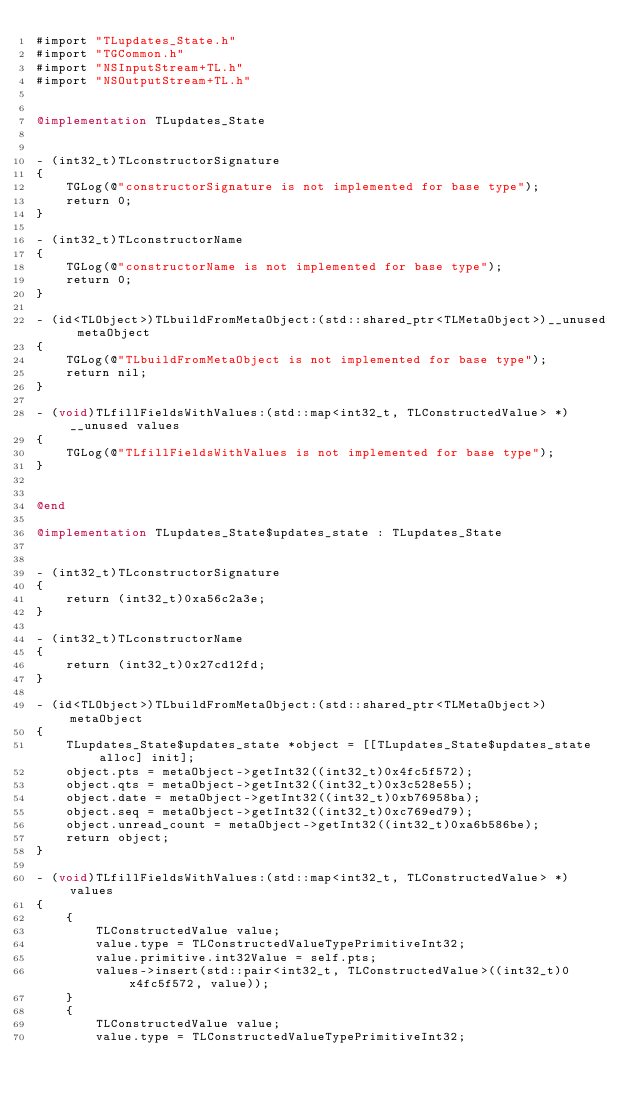<code> <loc_0><loc_0><loc_500><loc_500><_ObjectiveC_>#import "TLupdates_State.h"
#import "TGCommon.h"
#import "NSInputStream+TL.h"
#import "NSOutputStream+TL.h"


@implementation TLupdates_State


- (int32_t)TLconstructorSignature
{
    TGLog(@"constructorSignature is not implemented for base type");
    return 0;
}

- (int32_t)TLconstructorName
{
    TGLog(@"constructorName is not implemented for base type");
    return 0;
}

- (id<TLObject>)TLbuildFromMetaObject:(std::shared_ptr<TLMetaObject>)__unused metaObject
{
    TGLog(@"TLbuildFromMetaObject is not implemented for base type");
    return nil;
}

- (void)TLfillFieldsWithValues:(std::map<int32_t, TLConstructedValue> *)__unused values
{
    TGLog(@"TLfillFieldsWithValues is not implemented for base type");
}


@end

@implementation TLupdates_State$updates_state : TLupdates_State


- (int32_t)TLconstructorSignature
{
    return (int32_t)0xa56c2a3e;
}

- (int32_t)TLconstructorName
{
    return (int32_t)0x27cd12fd;
}

- (id<TLObject>)TLbuildFromMetaObject:(std::shared_ptr<TLMetaObject>)metaObject
{
    TLupdates_State$updates_state *object = [[TLupdates_State$updates_state alloc] init];
    object.pts = metaObject->getInt32((int32_t)0x4fc5f572);
    object.qts = metaObject->getInt32((int32_t)0x3c528e55);
    object.date = metaObject->getInt32((int32_t)0xb76958ba);
    object.seq = metaObject->getInt32((int32_t)0xc769ed79);
    object.unread_count = metaObject->getInt32((int32_t)0xa6b586be);
    return object;
}

- (void)TLfillFieldsWithValues:(std::map<int32_t, TLConstructedValue> *)values
{
    {
        TLConstructedValue value;
        value.type = TLConstructedValueTypePrimitiveInt32;
        value.primitive.int32Value = self.pts;
        values->insert(std::pair<int32_t, TLConstructedValue>((int32_t)0x4fc5f572, value));
    }
    {
        TLConstructedValue value;
        value.type = TLConstructedValueTypePrimitiveInt32;</code> 